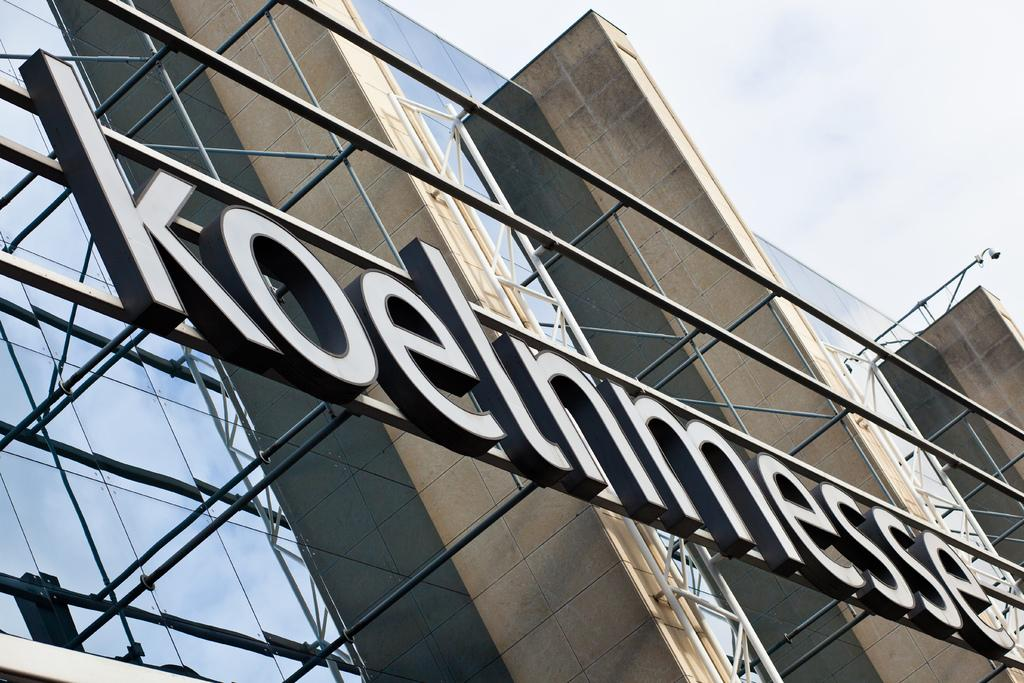What type of structures can be seen in the image? There are buildings in the image. Can you describe the lighting in the image? There is light visible in the image. What is visible at the top of the image? The sky is visible at the top of the image. What type of wrench is being used to measure the jail's dimensions in the image? There is no wrench, jail, or measurement activity present in the image. 